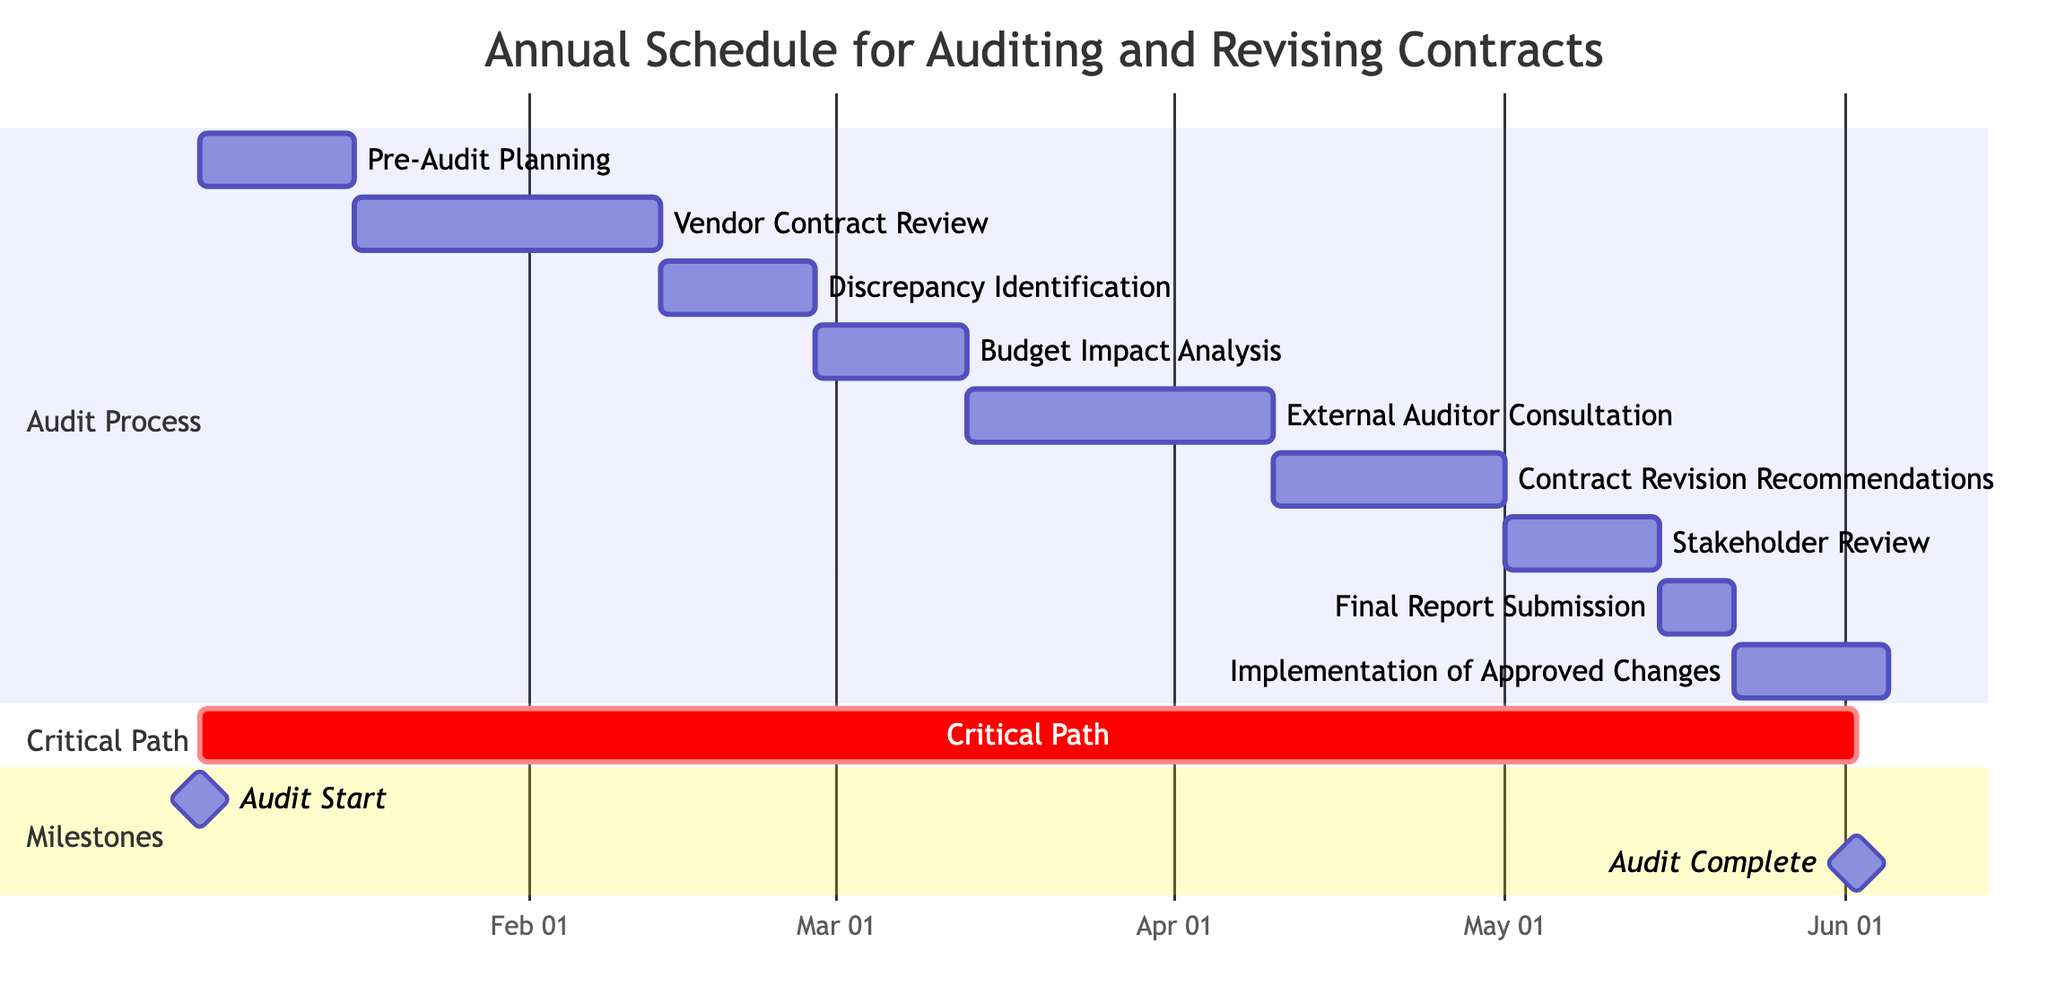What is the duration of the 'Vendor Contract Review' task? The 'Vendor Contract Review' task starts on January 16, 2023, and ends on February 10, 2023. The duration can be calculated as the difference in weeks between the start and end dates. From January 16 to February 10 is a total of 4 weeks.
Answer: 4 weeks What task follows 'Budget Impact Analysis'? Referring to the diagram, the 'Budget Impact Analysis' task is immediately followed by the 'External Auditor Consultation' task. There is a clear dependency showing this flow in the Gantt Chart.
Answer: External Auditor Consultation How many tasks are included in the 'Audit Process' section? To determine the number of tasks in the 'Audit Process' section, we can count each unique task listed under this section. There are a total of 9 tasks, starting from 'Pre-Audit Planning' to 'Implementation of Approved Changes.'
Answer: 9 What is the start date of the 'Stakeholder Review' task? Looking at the Gantt Chart, the 'Stakeholder Review' task begins on May 1, 2023. This specific date is indicated next to the task on the timeline.
Answer: May 1, 2023 Which task has the longest duration? By comparing the durations of all tasks listed, the task with the longest duration is 'Vendor Contract Review', which spans over 4 weeks. This is the longest individual duration as represented in the chart.
Answer: Vendor Contract Review What is the end date of the 'Implementation of Approved Changes' task? To find the end date of the 'Implementation of Approved Changes,' we follow the dependency chain from 'Final Report Submission.' This task ends on June 2, 2023, as indicated in the Gantt Chart.
Answer: June 2, 2023 Which tasks are scheduled to happen in March 2023? By reviewing the timeline, the tasks scheduled for March 2023 start with 'Budget Impact Analysis' from February 27 to March 10 and 'External Auditor Consultation' from March 13 to April 7. Both fall entirely inside the month of March.
Answer: Budget Impact Analysis, External Auditor Consultation What does the critical path encompass? The critical path can be identified by tracing the tasks that are dependent on one another to avoid delays. In this Gantt Chart, the critical path starts from 'Pre-Audit Planning' and extends to 'Implementation of Approved Changes.'
Answer: January 2, 2023 to June 2, 2023 